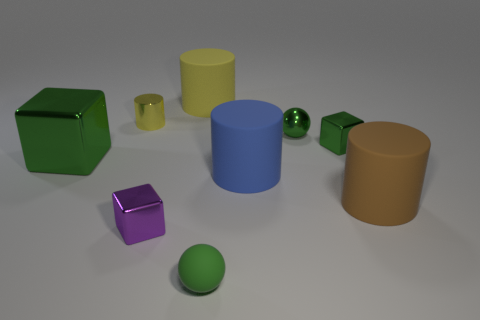Can you tell me the different shapes that are present in this image and how many there are of each? Certainly! In the image, there are three distinct shapes: cubes, cylinders, and spheres. There are two cubes (one green and one purple), three cylinders (yellow, blue, and brown), and two spheres (one green and one purple). 